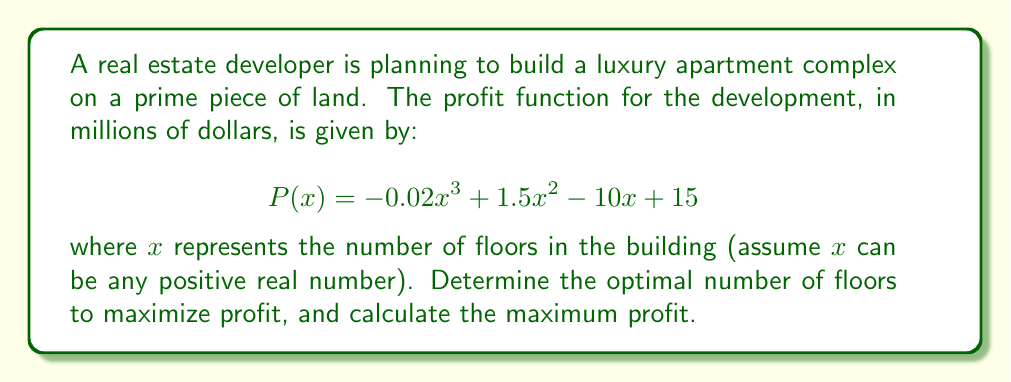Can you solve this math problem? To find the optimal number of floors that maximizes profit, we need to find the maximum of the profit function $P(x)$. This can be done using calculus by following these steps:

1. Find the first derivative of $P(x)$:
   $$P'(x) = -0.06x^2 + 3x - 10$$

2. Set the first derivative equal to zero and solve for x:
   $$-0.06x^2 + 3x - 10 = 0$$
   
   This is a quadratic equation. We can solve it using the quadratic formula:
   $$x = \frac{-b \pm \sqrt{b^2 - 4ac}}{2a}$$
   
   where $a = -0.06$, $b = 3$, and $c = -10$

   $$x = \frac{-3 \pm \sqrt{3^2 - 4(-0.06)(-10)}}{2(-0.06)}$$
   $$x = \frac{-3 \pm \sqrt{9 - 2.4}}{-0.12}$$
   $$x = \frac{-3 \pm \sqrt{6.6}}{-0.12}$$
   $$x = \frac{-3 \pm 2.569}{-0.12}$$

   This gives us two solutions:
   $$x_1 = \frac{-3 + 2.569}{-0.12} \approx 3.59$$
   $$x_2 = \frac{-3 - 2.569}{-0.12} \approx 46.41$$

3. To determine which solution gives the maximum profit, we need to check the second derivative:
   $$P''(x) = -0.12x + 3$$
   
   At $x = 3.59$: $P''(3.59) = -0.12(3.59) + 3 = 2.57 > 0$
   At $x = 46.41$: $P''(46.41) = -0.12(46.41) + 3 = -2.57 < 0$

   Since $P''(3.59) > 0$, this corresponds to a local minimum.
   Since $P''(46.41) < 0$, this corresponds to a local maximum.

4. Therefore, the optimal number of floors to maximize profit is approximately 46.41 floors.

5. To calculate the maximum profit, we substitute $x = 46.41$ into the original profit function:

   $$P(46.41) = -0.02(46.41)^3 + 1.5(46.41)^2 - 10(46.41) + 15$$
   $$\approx -1990.37 + 3230.31 - 464.10 + 15$$
   $$\approx 790.84$$

Thus, the maximum profit is approximately $790.84 million.
Answer: The optimal number of floors is approximately 46.41, and the maximum profit is approximately $790.84 million. 